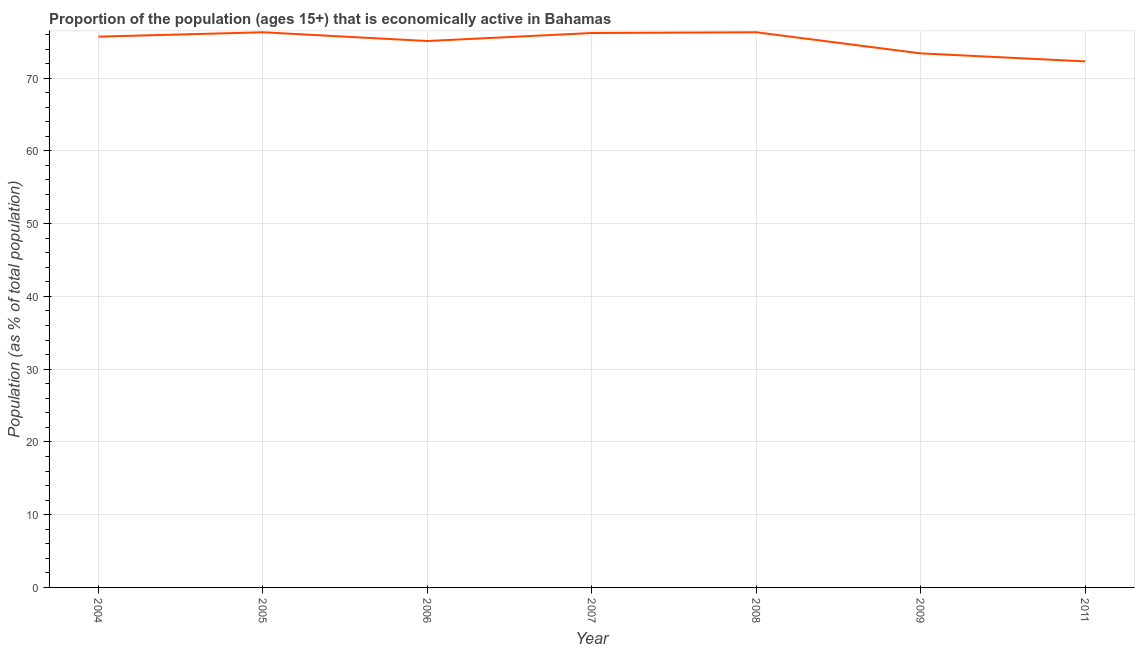What is the percentage of economically active population in 2006?
Provide a short and direct response. 75.1. Across all years, what is the maximum percentage of economically active population?
Provide a succinct answer. 76.3. Across all years, what is the minimum percentage of economically active population?
Keep it short and to the point. 72.3. In which year was the percentage of economically active population maximum?
Provide a short and direct response. 2005. In which year was the percentage of economically active population minimum?
Keep it short and to the point. 2011. What is the sum of the percentage of economically active population?
Provide a short and direct response. 525.3. What is the difference between the percentage of economically active population in 2004 and 2007?
Make the answer very short. -0.5. What is the average percentage of economically active population per year?
Keep it short and to the point. 75.04. What is the median percentage of economically active population?
Offer a terse response. 75.7. What is the ratio of the percentage of economically active population in 2005 to that in 2006?
Provide a short and direct response. 1.02. Is the difference between the percentage of economically active population in 2005 and 2011 greater than the difference between any two years?
Your answer should be compact. Yes. What is the difference between the highest and the second highest percentage of economically active population?
Your answer should be compact. 0. Does the percentage of economically active population monotonically increase over the years?
Offer a terse response. No. What is the title of the graph?
Your response must be concise. Proportion of the population (ages 15+) that is economically active in Bahamas. What is the label or title of the X-axis?
Provide a short and direct response. Year. What is the label or title of the Y-axis?
Offer a very short reply. Population (as % of total population). What is the Population (as % of total population) of 2004?
Keep it short and to the point. 75.7. What is the Population (as % of total population) in 2005?
Give a very brief answer. 76.3. What is the Population (as % of total population) of 2006?
Provide a succinct answer. 75.1. What is the Population (as % of total population) of 2007?
Provide a short and direct response. 76.2. What is the Population (as % of total population) in 2008?
Keep it short and to the point. 76.3. What is the Population (as % of total population) of 2009?
Ensure brevity in your answer.  73.4. What is the Population (as % of total population) in 2011?
Ensure brevity in your answer.  72.3. What is the difference between the Population (as % of total population) in 2004 and 2005?
Provide a succinct answer. -0.6. What is the difference between the Population (as % of total population) in 2004 and 2007?
Provide a succinct answer. -0.5. What is the difference between the Population (as % of total population) in 2004 and 2008?
Keep it short and to the point. -0.6. What is the difference between the Population (as % of total population) in 2004 and 2011?
Provide a short and direct response. 3.4. What is the difference between the Population (as % of total population) in 2005 and 2007?
Offer a terse response. 0.1. What is the difference between the Population (as % of total population) in 2006 and 2007?
Offer a terse response. -1.1. What is the difference between the Population (as % of total population) in 2006 and 2009?
Provide a succinct answer. 1.7. What is the difference between the Population (as % of total population) in 2006 and 2011?
Make the answer very short. 2.8. What is the difference between the Population (as % of total population) in 2007 and 2008?
Provide a succinct answer. -0.1. What is the difference between the Population (as % of total population) in 2007 and 2009?
Ensure brevity in your answer.  2.8. What is the difference between the Population (as % of total population) in 2007 and 2011?
Keep it short and to the point. 3.9. What is the difference between the Population (as % of total population) in 2008 and 2011?
Your answer should be compact. 4. What is the ratio of the Population (as % of total population) in 2004 to that in 2008?
Provide a short and direct response. 0.99. What is the ratio of the Population (as % of total population) in 2004 to that in 2009?
Your answer should be very brief. 1.03. What is the ratio of the Population (as % of total population) in 2004 to that in 2011?
Ensure brevity in your answer.  1.05. What is the ratio of the Population (as % of total population) in 2005 to that in 2006?
Your answer should be compact. 1.02. What is the ratio of the Population (as % of total population) in 2005 to that in 2009?
Provide a short and direct response. 1.04. What is the ratio of the Population (as % of total population) in 2005 to that in 2011?
Your response must be concise. 1.05. What is the ratio of the Population (as % of total population) in 2006 to that in 2007?
Offer a very short reply. 0.99. What is the ratio of the Population (as % of total population) in 2006 to that in 2009?
Your response must be concise. 1.02. What is the ratio of the Population (as % of total population) in 2006 to that in 2011?
Keep it short and to the point. 1.04. What is the ratio of the Population (as % of total population) in 2007 to that in 2008?
Make the answer very short. 1. What is the ratio of the Population (as % of total population) in 2007 to that in 2009?
Offer a very short reply. 1.04. What is the ratio of the Population (as % of total population) in 2007 to that in 2011?
Offer a very short reply. 1.05. What is the ratio of the Population (as % of total population) in 2008 to that in 2011?
Provide a succinct answer. 1.05. 